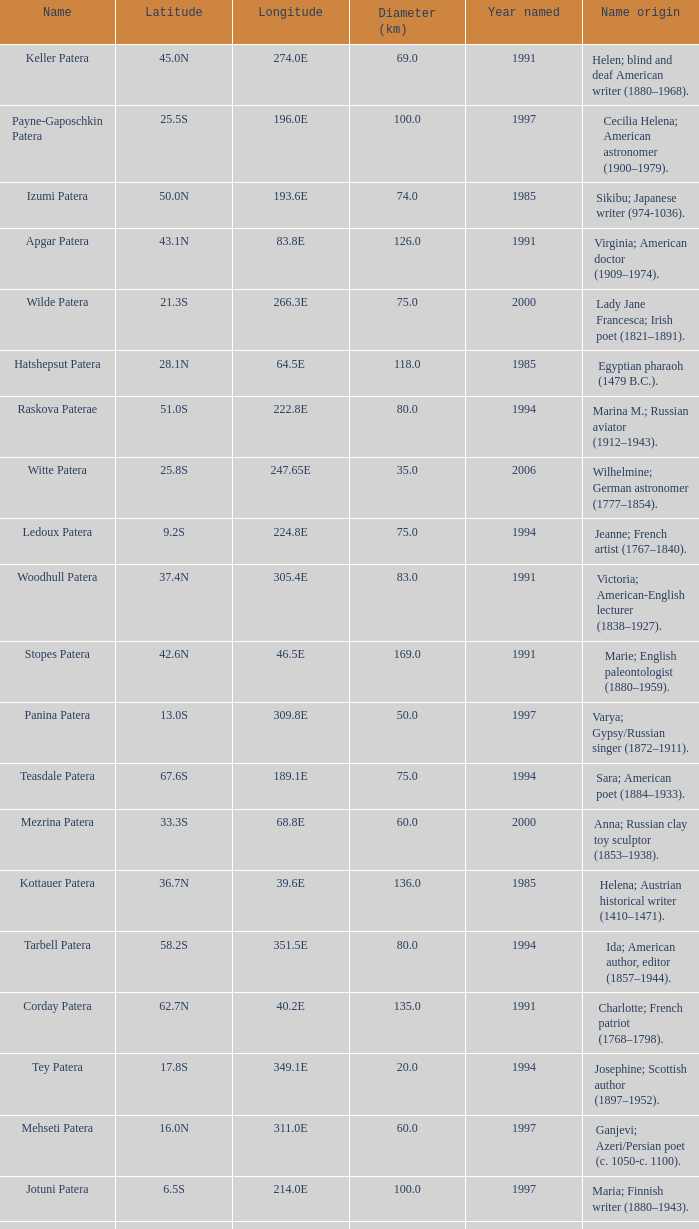What is the longitude of the feature named Razia Patera?  197.8E. 